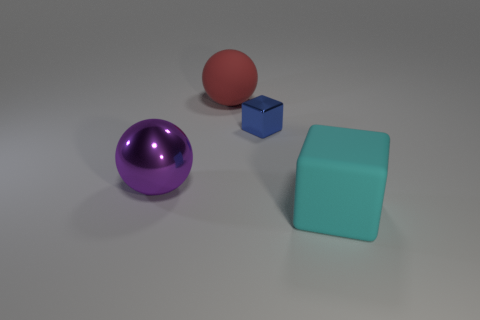What material appears to be used for the various objects and what does this suggest about their texture? The objects in the image appear to be made from a smooth, matte plastic, except for the purple sphere which seems to have a slightly glossy finish. This variety in texture suggests a visual and tactile contrast that makes the image more interesting and engaging, potentially emphasizing the different physical properties of materials. 